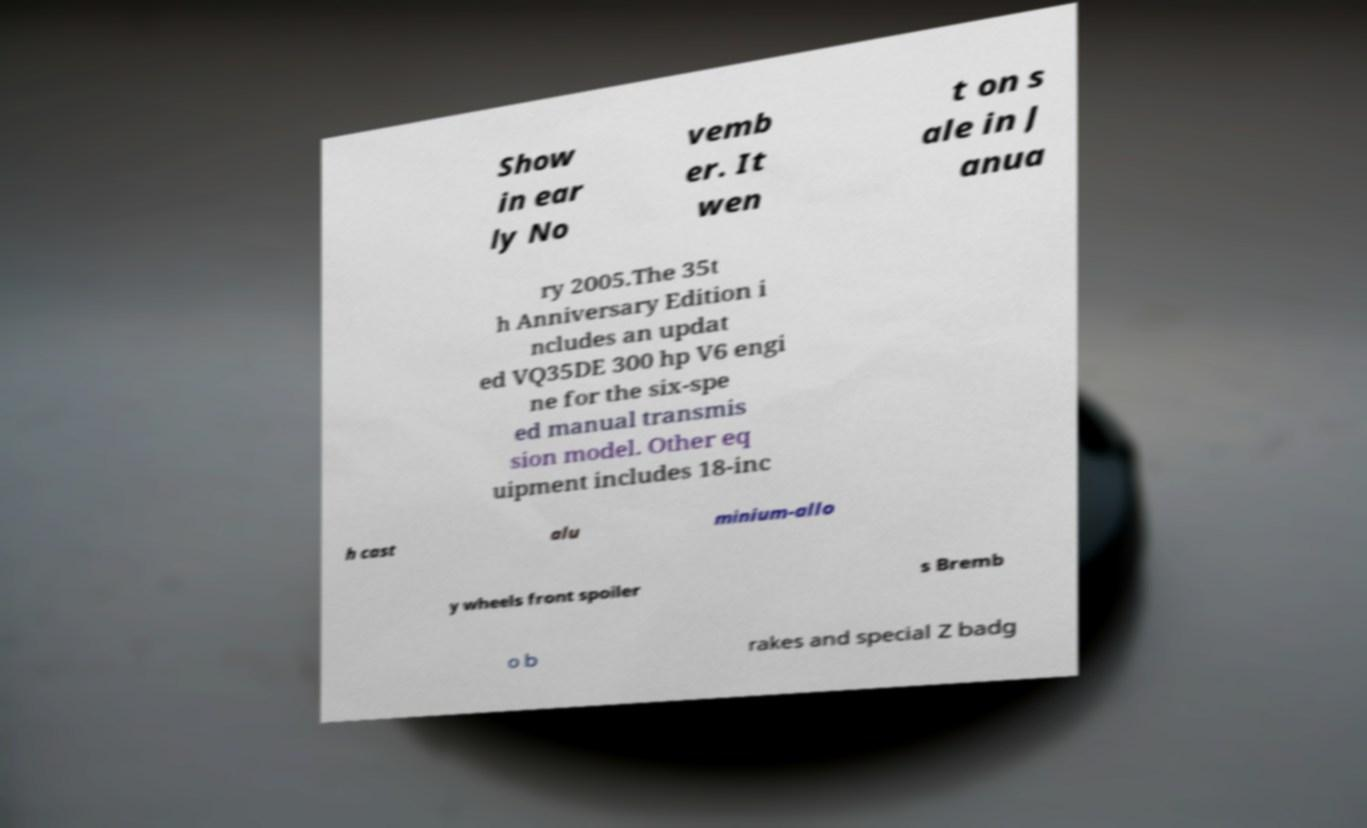Could you extract and type out the text from this image? Show in ear ly No vemb er. It wen t on s ale in J anua ry 2005.The 35t h Anniversary Edition i ncludes an updat ed VQ35DE 300 hp V6 engi ne for the six-spe ed manual transmis sion model. Other eq uipment includes 18-inc h cast alu minium-allo y wheels front spoiler s Bremb o b rakes and special Z badg 